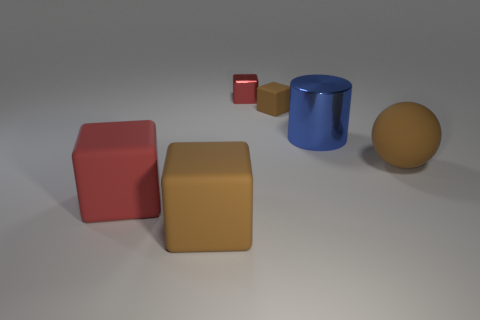Add 1 small blue cylinders. How many objects exist? 7 Subtract all blue cylinders. How many gray spheres are left? 0 Subtract all large red rubber things. Subtract all large blue metallic objects. How many objects are left? 4 Add 1 rubber blocks. How many rubber blocks are left? 4 Add 3 big cyan matte things. How many big cyan matte things exist? 3 Subtract all brown cubes. How many cubes are left? 2 Subtract all red matte cubes. How many cubes are left? 3 Subtract 0 gray cubes. How many objects are left? 6 Subtract all cylinders. How many objects are left? 5 Subtract 1 blocks. How many blocks are left? 3 